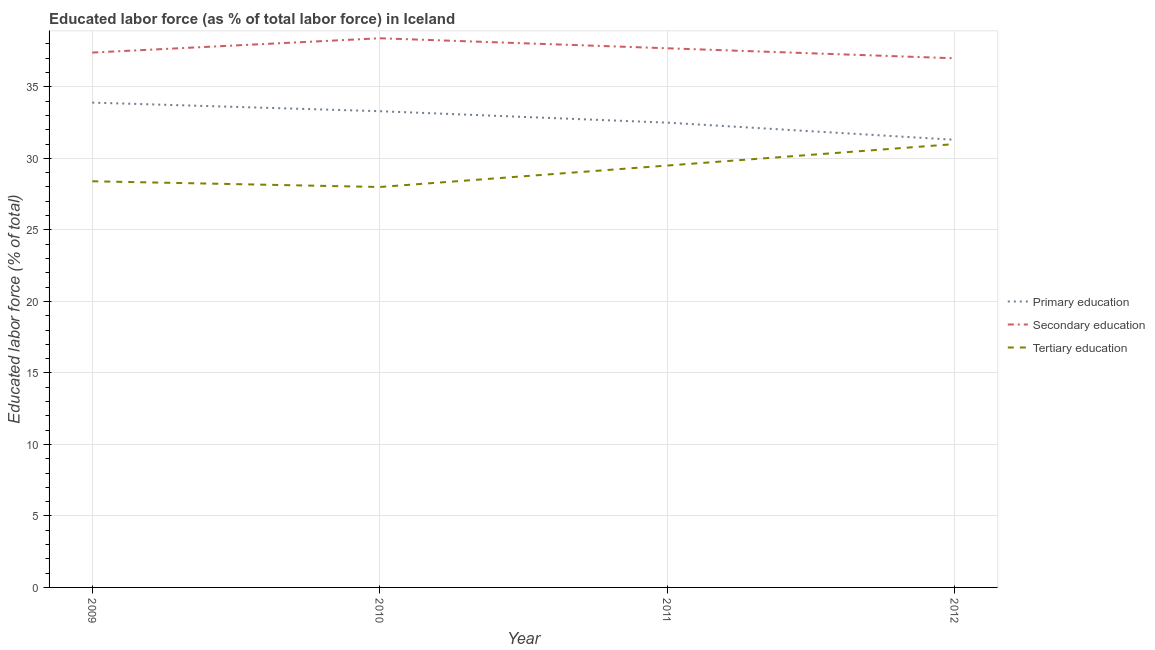How many different coloured lines are there?
Your answer should be compact. 3. Is the number of lines equal to the number of legend labels?
Your answer should be very brief. Yes. What is the percentage of labor force who received secondary education in 2011?
Provide a succinct answer. 37.7. Across all years, what is the maximum percentage of labor force who received primary education?
Keep it short and to the point. 33.9. Across all years, what is the minimum percentage of labor force who received secondary education?
Offer a very short reply. 37. In which year was the percentage of labor force who received secondary education minimum?
Your answer should be compact. 2012. What is the total percentage of labor force who received primary education in the graph?
Provide a succinct answer. 131. What is the difference between the percentage of labor force who received tertiary education in 2009 and that in 2010?
Your answer should be compact. 0.4. What is the difference between the percentage of labor force who received primary education in 2012 and the percentage of labor force who received tertiary education in 2011?
Make the answer very short. 1.8. What is the average percentage of labor force who received primary education per year?
Make the answer very short. 32.75. In the year 2012, what is the difference between the percentage of labor force who received primary education and percentage of labor force who received tertiary education?
Your answer should be very brief. 0.3. What is the ratio of the percentage of labor force who received secondary education in 2010 to that in 2011?
Give a very brief answer. 1.02. What is the difference between the highest and the second highest percentage of labor force who received primary education?
Ensure brevity in your answer.  0.6. What is the difference between the highest and the lowest percentage of labor force who received primary education?
Offer a very short reply. 2.6. Is the sum of the percentage of labor force who received secondary education in 2010 and 2011 greater than the maximum percentage of labor force who received tertiary education across all years?
Your answer should be compact. Yes. Does the percentage of labor force who received primary education monotonically increase over the years?
Your answer should be very brief. No. Is the percentage of labor force who received primary education strictly less than the percentage of labor force who received secondary education over the years?
Ensure brevity in your answer.  Yes. What is the difference between two consecutive major ticks on the Y-axis?
Give a very brief answer. 5. Are the values on the major ticks of Y-axis written in scientific E-notation?
Ensure brevity in your answer.  No. Does the graph contain grids?
Offer a terse response. Yes. How many legend labels are there?
Provide a short and direct response. 3. What is the title of the graph?
Provide a succinct answer. Educated labor force (as % of total labor force) in Iceland. Does "Private sector" appear as one of the legend labels in the graph?
Provide a short and direct response. No. What is the label or title of the Y-axis?
Your response must be concise. Educated labor force (% of total). What is the Educated labor force (% of total) in Primary education in 2009?
Provide a short and direct response. 33.9. What is the Educated labor force (% of total) in Secondary education in 2009?
Your answer should be very brief. 37.4. What is the Educated labor force (% of total) of Tertiary education in 2009?
Provide a short and direct response. 28.4. What is the Educated labor force (% of total) in Primary education in 2010?
Your answer should be very brief. 33.3. What is the Educated labor force (% of total) of Secondary education in 2010?
Your answer should be very brief. 38.4. What is the Educated labor force (% of total) in Tertiary education in 2010?
Offer a terse response. 28. What is the Educated labor force (% of total) of Primary education in 2011?
Offer a very short reply. 32.5. What is the Educated labor force (% of total) of Secondary education in 2011?
Your answer should be compact. 37.7. What is the Educated labor force (% of total) in Tertiary education in 2011?
Your response must be concise. 29.5. What is the Educated labor force (% of total) of Primary education in 2012?
Ensure brevity in your answer.  31.3. Across all years, what is the maximum Educated labor force (% of total) of Primary education?
Offer a terse response. 33.9. Across all years, what is the maximum Educated labor force (% of total) in Secondary education?
Provide a short and direct response. 38.4. Across all years, what is the minimum Educated labor force (% of total) of Primary education?
Give a very brief answer. 31.3. Across all years, what is the minimum Educated labor force (% of total) of Secondary education?
Ensure brevity in your answer.  37. What is the total Educated labor force (% of total) of Primary education in the graph?
Your answer should be very brief. 131. What is the total Educated labor force (% of total) of Secondary education in the graph?
Provide a succinct answer. 150.5. What is the total Educated labor force (% of total) in Tertiary education in the graph?
Offer a very short reply. 116.9. What is the difference between the Educated labor force (% of total) in Secondary education in 2009 and that in 2010?
Your response must be concise. -1. What is the difference between the Educated labor force (% of total) in Primary education in 2009 and that in 2011?
Give a very brief answer. 1.4. What is the difference between the Educated labor force (% of total) in Secondary education in 2009 and that in 2011?
Your answer should be very brief. -0.3. What is the difference between the Educated labor force (% of total) in Secondary education in 2009 and that in 2012?
Provide a succinct answer. 0.4. What is the difference between the Educated labor force (% of total) of Primary education in 2010 and that in 2011?
Keep it short and to the point. 0.8. What is the difference between the Educated labor force (% of total) of Primary education in 2010 and that in 2012?
Provide a succinct answer. 2. What is the difference between the Educated labor force (% of total) in Secondary education in 2010 and that in 2012?
Offer a terse response. 1.4. What is the difference between the Educated labor force (% of total) in Primary education in 2011 and that in 2012?
Your answer should be very brief. 1.2. What is the difference between the Educated labor force (% of total) of Secondary education in 2011 and that in 2012?
Give a very brief answer. 0.7. What is the difference between the Educated labor force (% of total) in Tertiary education in 2011 and that in 2012?
Offer a very short reply. -1.5. What is the difference between the Educated labor force (% of total) in Primary education in 2009 and the Educated labor force (% of total) in Tertiary education in 2010?
Your response must be concise. 5.9. What is the difference between the Educated labor force (% of total) of Primary education in 2009 and the Educated labor force (% of total) of Secondary education in 2012?
Your response must be concise. -3.1. What is the difference between the Educated labor force (% of total) in Primary education in 2009 and the Educated labor force (% of total) in Tertiary education in 2012?
Your response must be concise. 2.9. What is the difference between the Educated labor force (% of total) of Secondary education in 2009 and the Educated labor force (% of total) of Tertiary education in 2012?
Keep it short and to the point. 6.4. What is the difference between the Educated labor force (% of total) of Primary education in 2010 and the Educated labor force (% of total) of Secondary education in 2011?
Your answer should be compact. -4.4. What is the difference between the Educated labor force (% of total) of Secondary education in 2010 and the Educated labor force (% of total) of Tertiary education in 2011?
Provide a succinct answer. 8.9. What is the average Educated labor force (% of total) in Primary education per year?
Offer a terse response. 32.75. What is the average Educated labor force (% of total) in Secondary education per year?
Ensure brevity in your answer.  37.62. What is the average Educated labor force (% of total) of Tertiary education per year?
Ensure brevity in your answer.  29.23. In the year 2009, what is the difference between the Educated labor force (% of total) in Primary education and Educated labor force (% of total) in Secondary education?
Give a very brief answer. -3.5. In the year 2010, what is the difference between the Educated labor force (% of total) of Primary education and Educated labor force (% of total) of Secondary education?
Give a very brief answer. -5.1. In the year 2010, what is the difference between the Educated labor force (% of total) of Secondary education and Educated labor force (% of total) of Tertiary education?
Your response must be concise. 10.4. In the year 2011, what is the difference between the Educated labor force (% of total) of Primary education and Educated labor force (% of total) of Secondary education?
Offer a terse response. -5.2. In the year 2011, what is the difference between the Educated labor force (% of total) in Secondary education and Educated labor force (% of total) in Tertiary education?
Your response must be concise. 8.2. In the year 2012, what is the difference between the Educated labor force (% of total) in Primary education and Educated labor force (% of total) in Secondary education?
Offer a very short reply. -5.7. In the year 2012, what is the difference between the Educated labor force (% of total) of Primary education and Educated labor force (% of total) of Tertiary education?
Your answer should be very brief. 0.3. In the year 2012, what is the difference between the Educated labor force (% of total) in Secondary education and Educated labor force (% of total) in Tertiary education?
Your answer should be very brief. 6. What is the ratio of the Educated labor force (% of total) of Primary education in 2009 to that in 2010?
Give a very brief answer. 1.02. What is the ratio of the Educated labor force (% of total) in Secondary education in 2009 to that in 2010?
Your answer should be compact. 0.97. What is the ratio of the Educated labor force (% of total) of Tertiary education in 2009 to that in 2010?
Offer a terse response. 1.01. What is the ratio of the Educated labor force (% of total) in Primary education in 2009 to that in 2011?
Offer a very short reply. 1.04. What is the ratio of the Educated labor force (% of total) of Tertiary education in 2009 to that in 2011?
Offer a terse response. 0.96. What is the ratio of the Educated labor force (% of total) of Primary education in 2009 to that in 2012?
Offer a very short reply. 1.08. What is the ratio of the Educated labor force (% of total) of Secondary education in 2009 to that in 2012?
Provide a short and direct response. 1.01. What is the ratio of the Educated labor force (% of total) of Tertiary education in 2009 to that in 2012?
Offer a very short reply. 0.92. What is the ratio of the Educated labor force (% of total) in Primary education in 2010 to that in 2011?
Ensure brevity in your answer.  1.02. What is the ratio of the Educated labor force (% of total) of Secondary education in 2010 to that in 2011?
Ensure brevity in your answer.  1.02. What is the ratio of the Educated labor force (% of total) of Tertiary education in 2010 to that in 2011?
Offer a very short reply. 0.95. What is the ratio of the Educated labor force (% of total) of Primary education in 2010 to that in 2012?
Provide a short and direct response. 1.06. What is the ratio of the Educated labor force (% of total) of Secondary education in 2010 to that in 2012?
Ensure brevity in your answer.  1.04. What is the ratio of the Educated labor force (% of total) of Tertiary education in 2010 to that in 2012?
Make the answer very short. 0.9. What is the ratio of the Educated labor force (% of total) of Primary education in 2011 to that in 2012?
Offer a terse response. 1.04. What is the ratio of the Educated labor force (% of total) in Secondary education in 2011 to that in 2012?
Keep it short and to the point. 1.02. What is the ratio of the Educated labor force (% of total) of Tertiary education in 2011 to that in 2012?
Your answer should be very brief. 0.95. What is the difference between the highest and the second highest Educated labor force (% of total) of Secondary education?
Provide a succinct answer. 0.7. What is the difference between the highest and the lowest Educated labor force (% of total) of Primary education?
Provide a succinct answer. 2.6. What is the difference between the highest and the lowest Educated labor force (% of total) in Secondary education?
Keep it short and to the point. 1.4. 